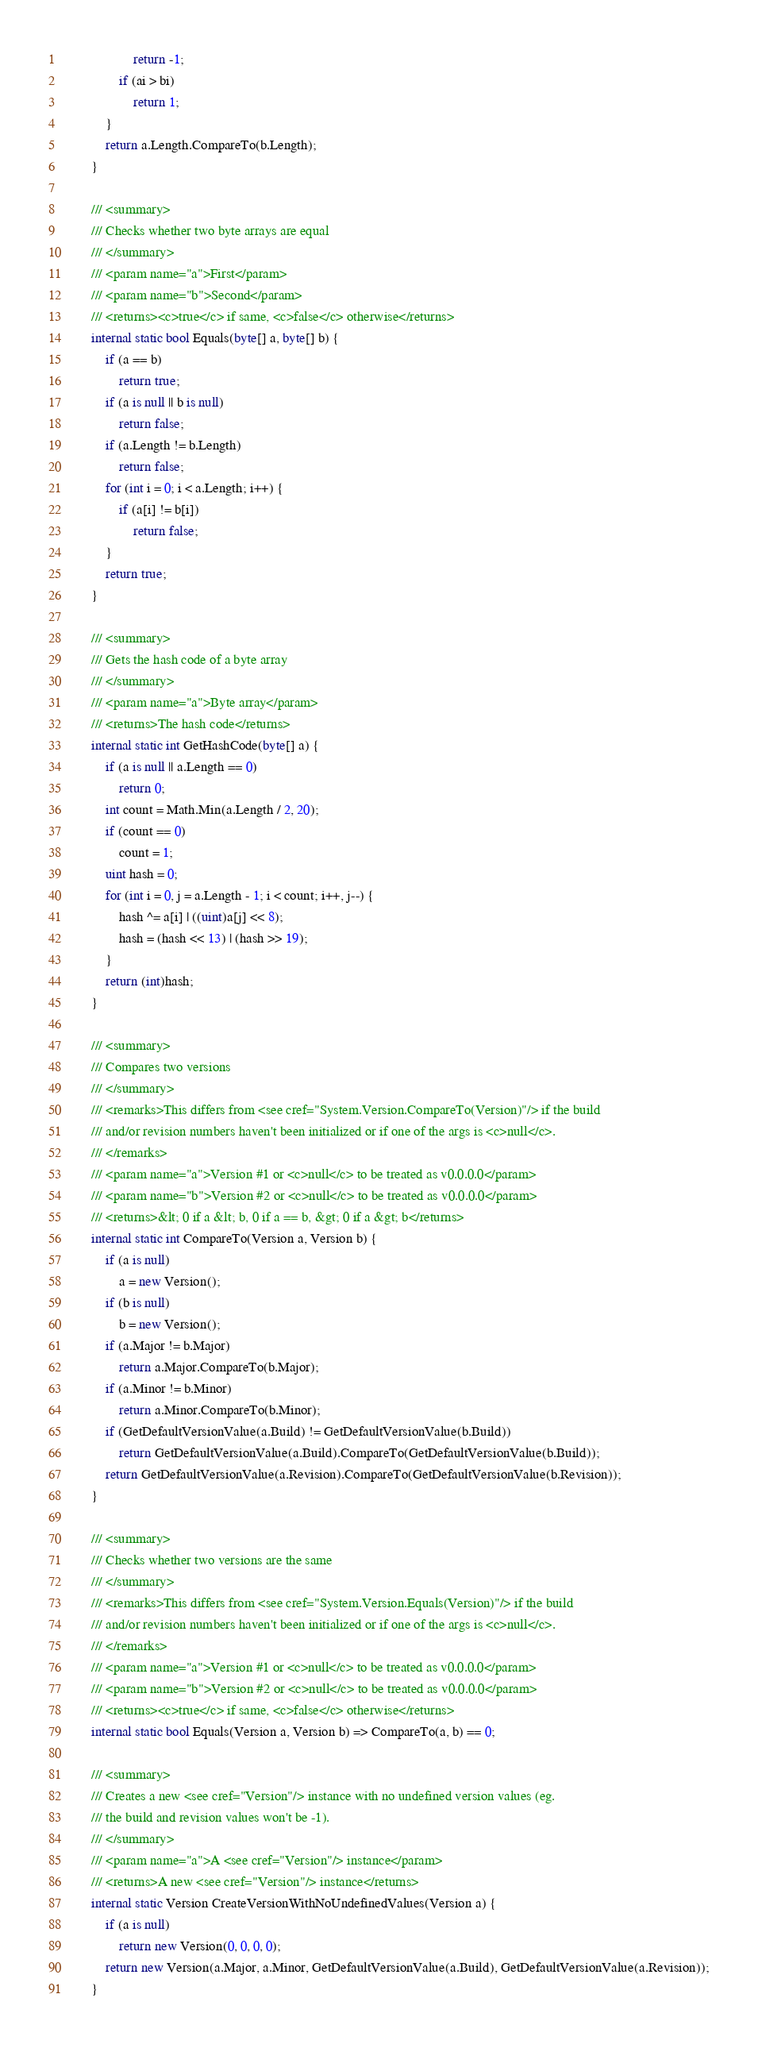Convert code to text. <code><loc_0><loc_0><loc_500><loc_500><_C#_>					return -1;
				if (ai > bi)
					return 1;
			}
			return a.Length.CompareTo(b.Length);
		}

		/// <summary>
		/// Checks whether two byte arrays are equal
		/// </summary>
		/// <param name="a">First</param>
		/// <param name="b">Second</param>
		/// <returns><c>true</c> if same, <c>false</c> otherwise</returns>
		internal static bool Equals(byte[] a, byte[] b) {
			if (a == b)
				return true;
			if (a is null || b is null)
				return false;
			if (a.Length != b.Length)
				return false;
			for (int i = 0; i < a.Length; i++) {
				if (a[i] != b[i])
					return false;
			}
			return true;
		}

		/// <summary>
		/// Gets the hash code of a byte array
		/// </summary>
		/// <param name="a">Byte array</param>
		/// <returns>The hash code</returns>
		internal static int GetHashCode(byte[] a) {
			if (a is null || a.Length == 0)
				return 0;
			int count = Math.Min(a.Length / 2, 20);
			if (count == 0)
				count = 1;
			uint hash = 0;
			for (int i = 0, j = a.Length - 1; i < count; i++, j--) {
				hash ^= a[i] | ((uint)a[j] << 8);
				hash = (hash << 13) | (hash >> 19);
			}
			return (int)hash;
		}

		/// <summary>
		/// Compares two versions
		/// </summary>
		/// <remarks>This differs from <see cref="System.Version.CompareTo(Version)"/> if the build
		/// and/or revision numbers haven't been initialized or if one of the args is <c>null</c>.
		/// </remarks>
		/// <param name="a">Version #1 or <c>null</c> to be treated as v0.0.0.0</param>
		/// <param name="b">Version #2 or <c>null</c> to be treated as v0.0.0.0</param>
		/// <returns>&lt; 0 if a &lt; b, 0 if a == b, &gt; 0 if a &gt; b</returns>
		internal static int CompareTo(Version a, Version b) {
			if (a is null)
				a = new Version();
			if (b is null)
				b = new Version();
			if (a.Major != b.Major)
				return a.Major.CompareTo(b.Major);
			if (a.Minor != b.Minor)
				return a.Minor.CompareTo(b.Minor);
			if (GetDefaultVersionValue(a.Build) != GetDefaultVersionValue(b.Build))
				return GetDefaultVersionValue(a.Build).CompareTo(GetDefaultVersionValue(b.Build));
			return GetDefaultVersionValue(a.Revision).CompareTo(GetDefaultVersionValue(b.Revision));
		}

		/// <summary>
		/// Checks whether two versions are the same
		/// </summary>
		/// <remarks>This differs from <see cref="System.Version.Equals(Version)"/> if the build
		/// and/or revision numbers haven't been initialized or if one of the args is <c>null</c>.
		/// </remarks>
		/// <param name="a">Version #1 or <c>null</c> to be treated as v0.0.0.0</param>
		/// <param name="b">Version #2 or <c>null</c> to be treated as v0.0.0.0</param>
		/// <returns><c>true</c> if same, <c>false</c> otherwise</returns>
		internal static bool Equals(Version a, Version b) => CompareTo(a, b) == 0;

		/// <summary>
		/// Creates a new <see cref="Version"/> instance with no undefined version values (eg.
		/// the build and revision values won't be -1).
		/// </summary>
		/// <param name="a">A <see cref="Version"/> instance</param>
		/// <returns>A new <see cref="Version"/> instance</returns>
		internal static Version CreateVersionWithNoUndefinedValues(Version a) {
			if (a is null)
				return new Version(0, 0, 0, 0);
			return new Version(a.Major, a.Minor, GetDefaultVersionValue(a.Build), GetDefaultVersionValue(a.Revision));
		}
</code> 